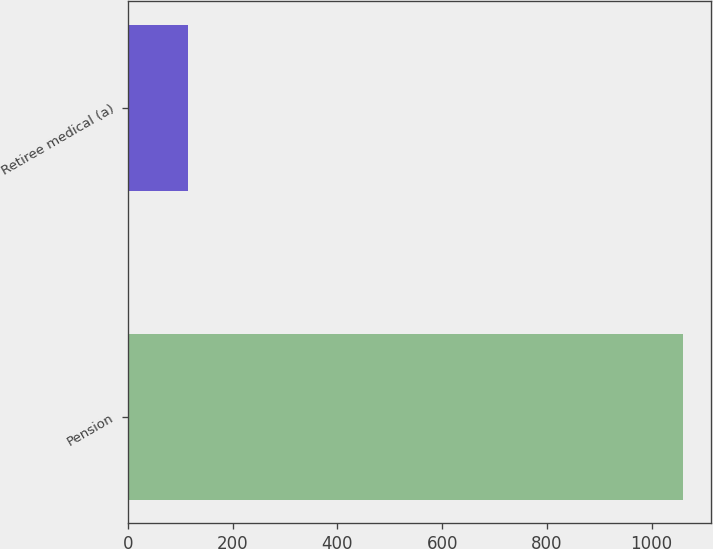<chart> <loc_0><loc_0><loc_500><loc_500><bar_chart><fcel>Pension<fcel>Retiree medical (a)<nl><fcel>1060<fcel>115<nl></chart> 